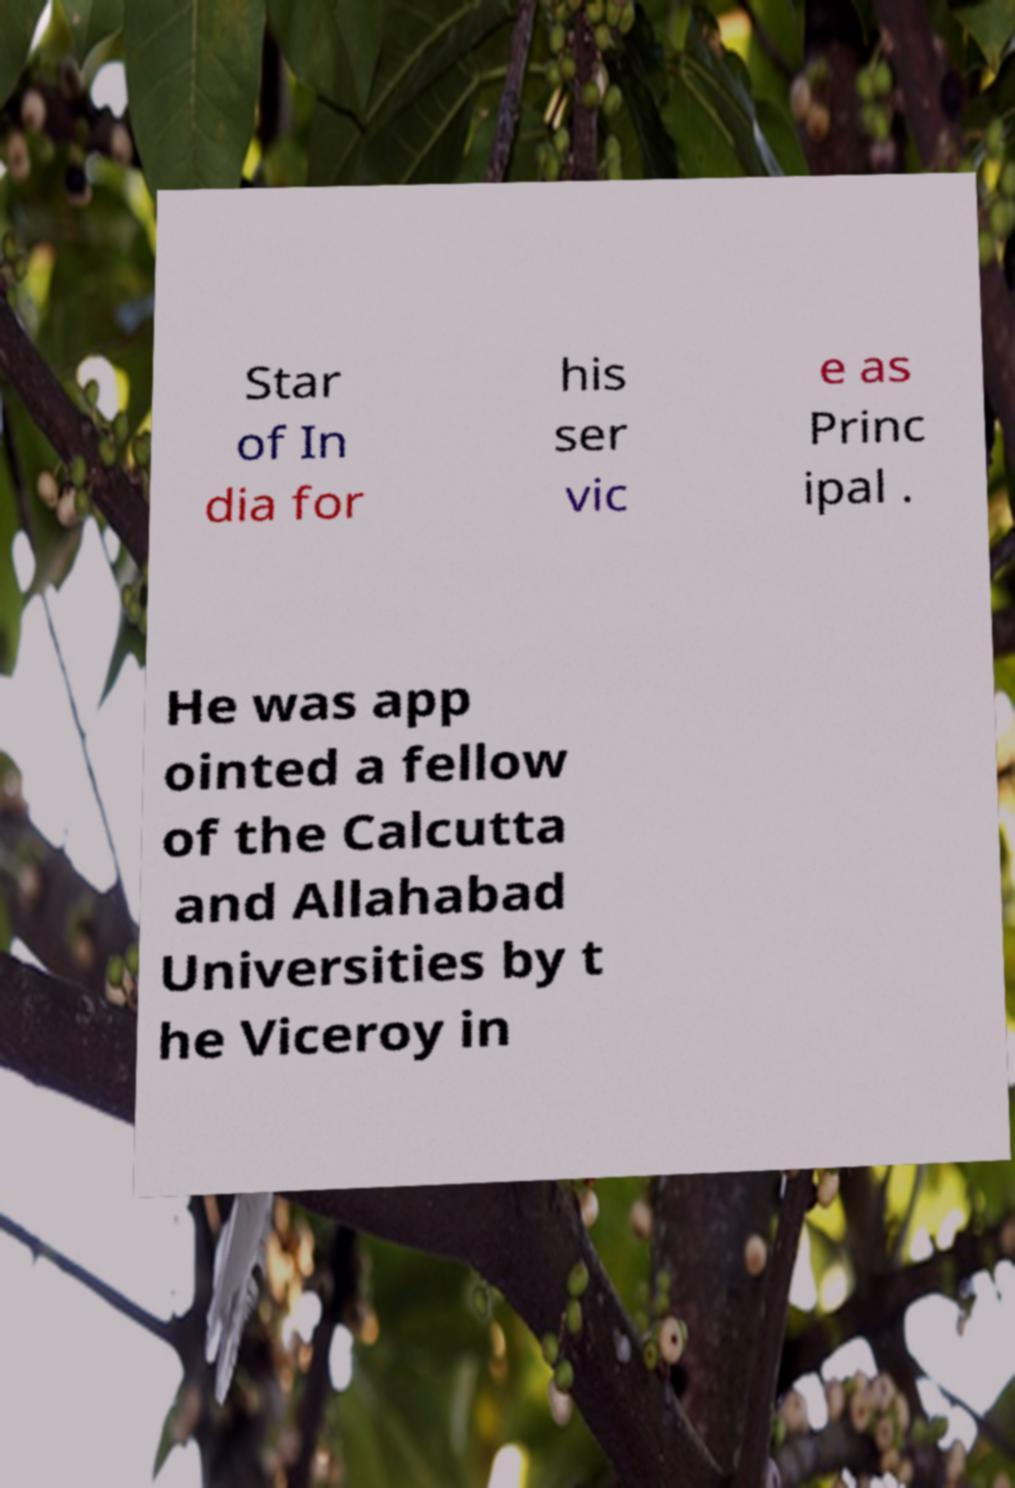What messages or text are displayed in this image? I need them in a readable, typed format. Star of In dia for his ser vic e as Princ ipal . He was app ointed a fellow of the Calcutta and Allahabad Universities by t he Viceroy in 